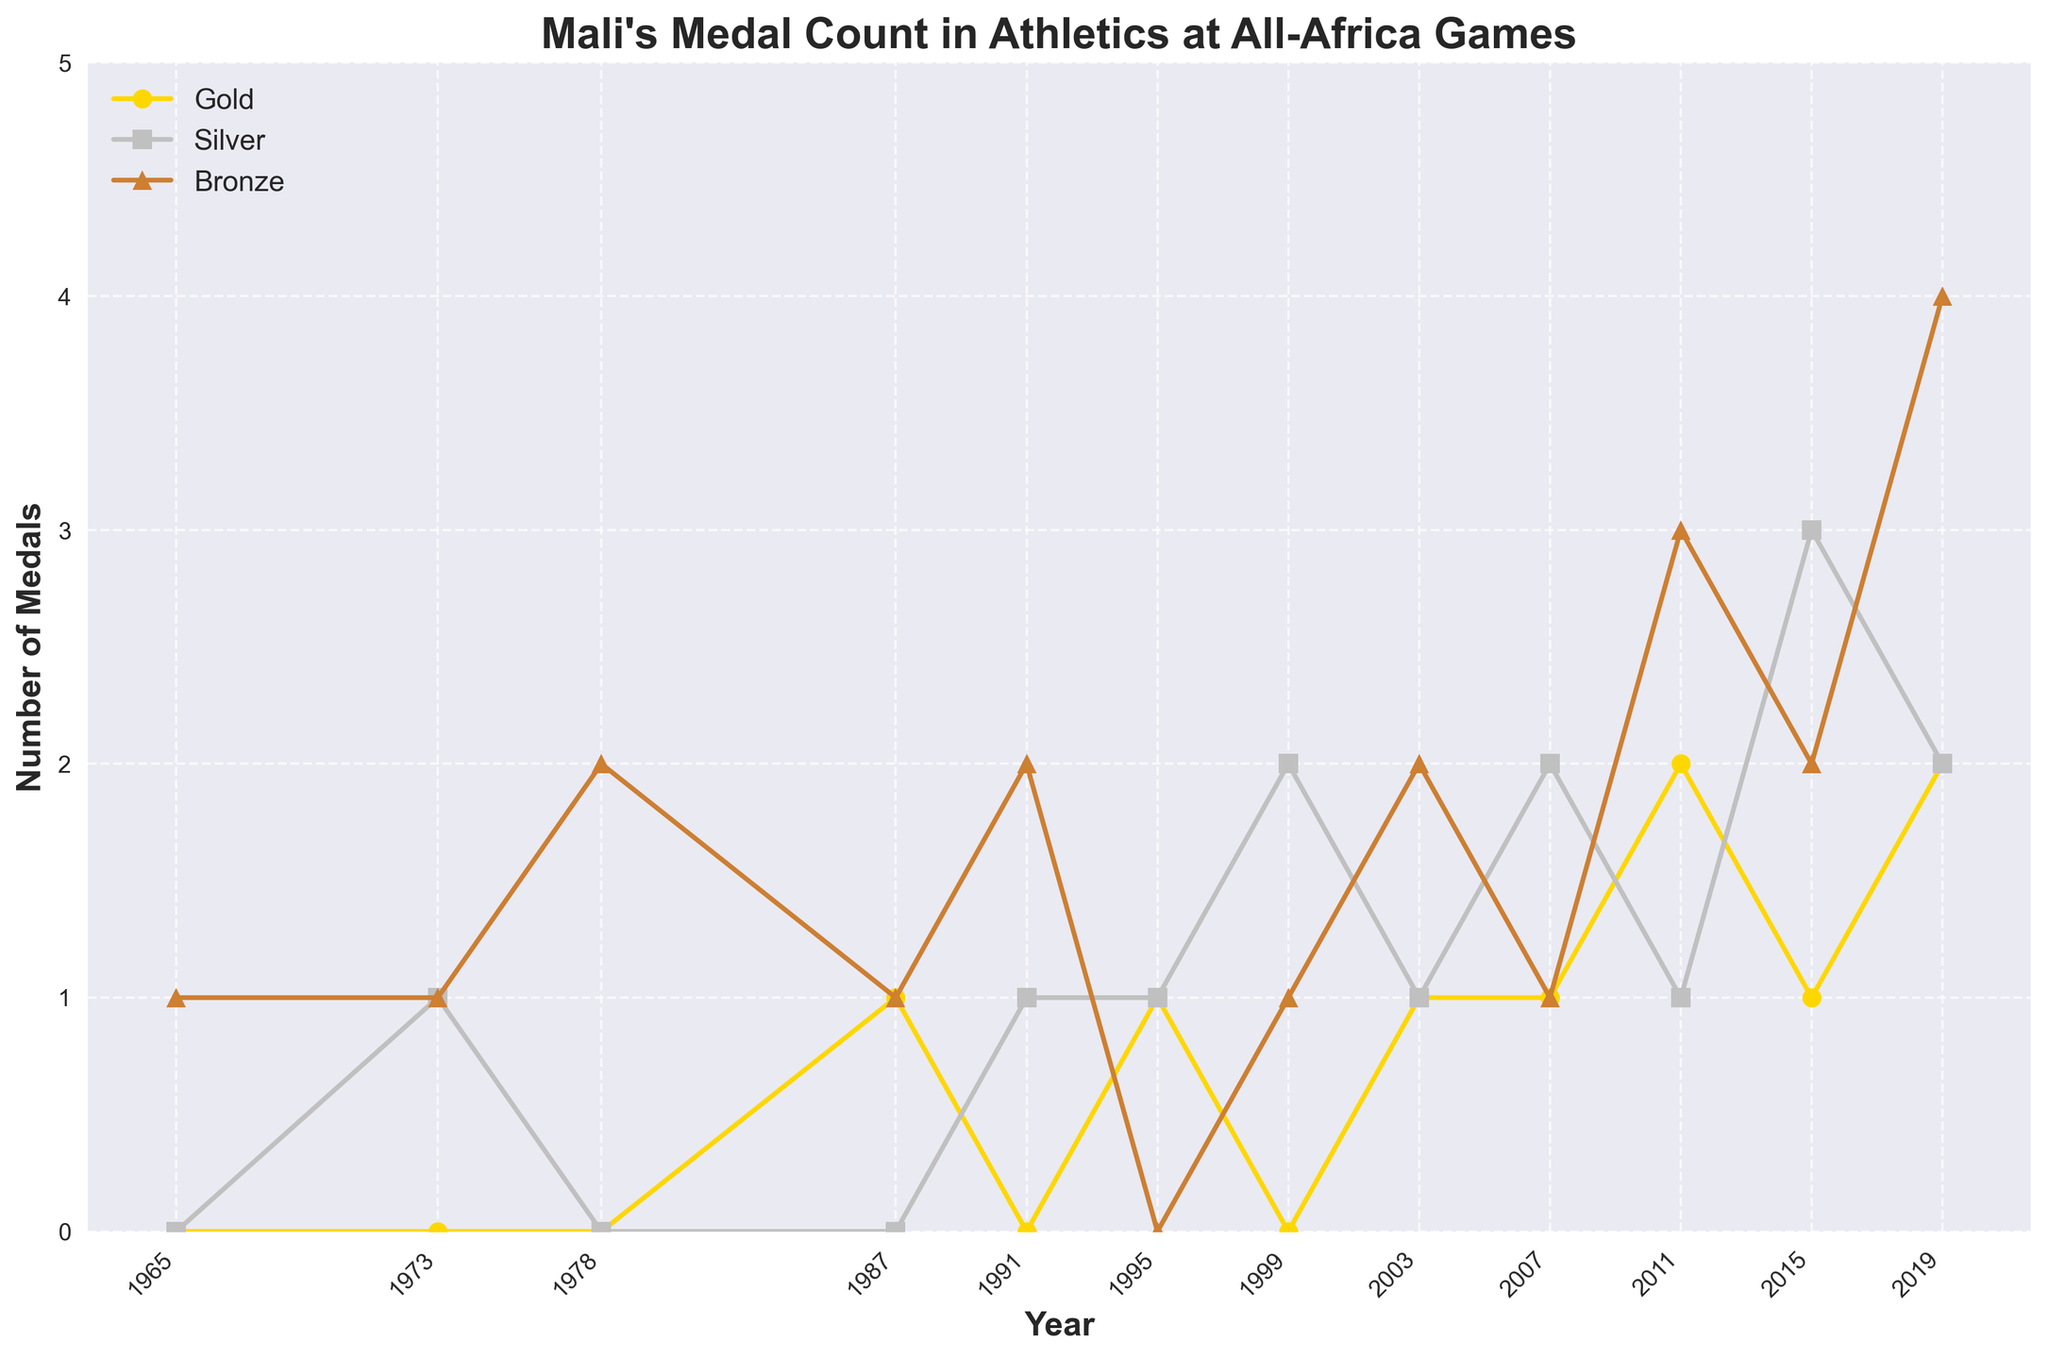How many total medals did Mali win in 2011? To get the total medals won by Mali in 2011, we need to add up the gold, silver, and bronze medals. Referring to the figure, in 2011, Mali won 2 gold, 1 silver, and 3 bronze medals. Summing these up: 2 + 1 + 3 = 6.
Answer: 6 Which year did Mali win the most bronze medals? We need to look at the bronze medal line on the chart and identify the year with the highest peak. The highest number of bronze medals is 4, which occurs in 2019.
Answer: 2019 Did Mali win more gold medals or silver medals in 2003? By inspecting the gold and silver medal lines for the year 2003, Mali won 1 gold medal and 1 silver medal, meaning they won the same number of gold and silver medals.
Answer: Equal Which year shows the first occurrence of a gold medal for Mali? The first occurrence of a gold medal can be found by identifying the first non-zero value on the gold medal line. This happens in 1987.
Answer: 1987 In which year did Mali achieve its highest combined total of gold and silver medals? To find this, we need to look at the sum of gold and silver medals for each year. The highest sum occurs in 2011 with 2 gold and 1 silver (total 3).
Answer: 2011 Compare the total medal counts between 1991 and 1995. Which year had more? For 1991, the medals are 0 gold, 1 silver, and 2 bronze (total = 3). For 1995, the medals are 1 gold, 1 silver, and 0 bronze (total = 2). 1991 has more medals than 1995.
Answer: 1991 How many times has Mali won exactly 1 gold medal in a single year? We need to count the occurrences on the gold medal line where the value is exactly 1. These years are 1987, 1995, 2003, 2007, and 2015, making it 5 times.
Answer: 5 What is the difference in the number of silver medals won between 1973 and 2019? Mali won 1 silver medal in 1973 and 2 silver medals in 2019. The difference is 2 - 1 = 1.
Answer: 1 Which medal type shows the greatest increase from 1965 to 2019? By looking at the difference in the number of each type of medal between 1965 and 2019: Gold increased from 0 to 2, Silver increased from 0 to 2, and Bronze increased from 1 to 4. The greatest increase is in bronze medals (4 - 1 = 3).
Answer: Bronze How many medals in total did Mali win across all All-Africa Games until 2019? We need to sum all the gold, silver, and bronze medals from the data. The totals are: 9 gold, 15 silver, and 20 bronze. Summing these, 9 + 15 + 20 = 44.
Answer: 44 